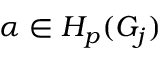<formula> <loc_0><loc_0><loc_500><loc_500>\alpha \in H _ { p } ( G _ { j } )</formula> 